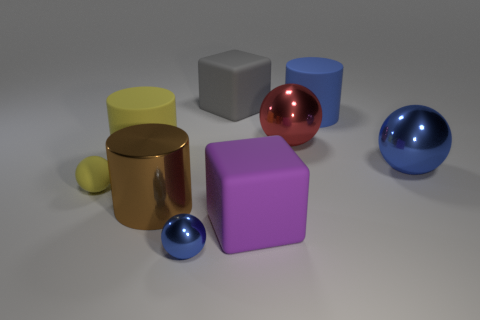What is the shape of the big object in front of the big brown shiny cylinder?
Provide a succinct answer. Cube. What size is the brown cylinder that is made of the same material as the big red thing?
Offer a very short reply. Large. How many big red shiny things are the same shape as the small shiny object?
Make the answer very short. 1. Does the big rubber cylinder that is right of the big metal cylinder have the same color as the small metallic ball?
Ensure brevity in your answer.  Yes. There is a tiny object that is in front of the big rubber cube that is in front of the large yellow thing; how many tiny objects are to the right of it?
Your response must be concise. 0. What number of blue things are behind the small yellow rubber sphere and in front of the large blue cylinder?
Your response must be concise. 1. The shiny thing that is the same color as the small metallic sphere is what shape?
Give a very brief answer. Sphere. Are the big purple object and the tiny blue object made of the same material?
Ensure brevity in your answer.  No. The big shiny object that is on the left side of the big rubber block that is behind the blue ball that is behind the large purple thing is what shape?
Make the answer very short. Cylinder. Is the number of large gray blocks that are in front of the large brown thing less than the number of rubber things that are to the right of the tiny blue metal sphere?
Make the answer very short. Yes. 